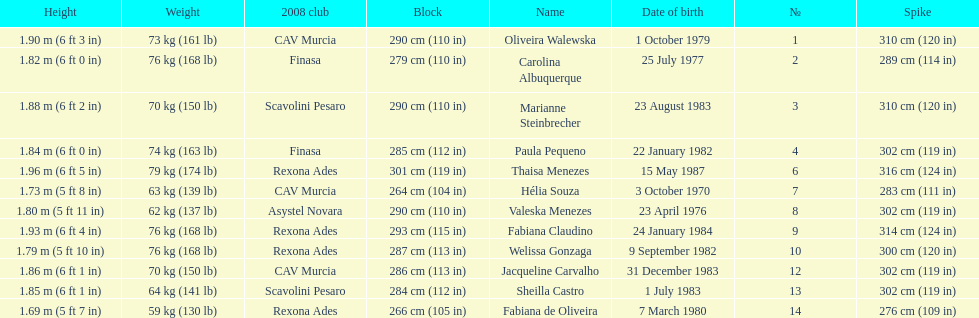Who is the next tallest player after thaisa menezes? Fabiana Claudino. 